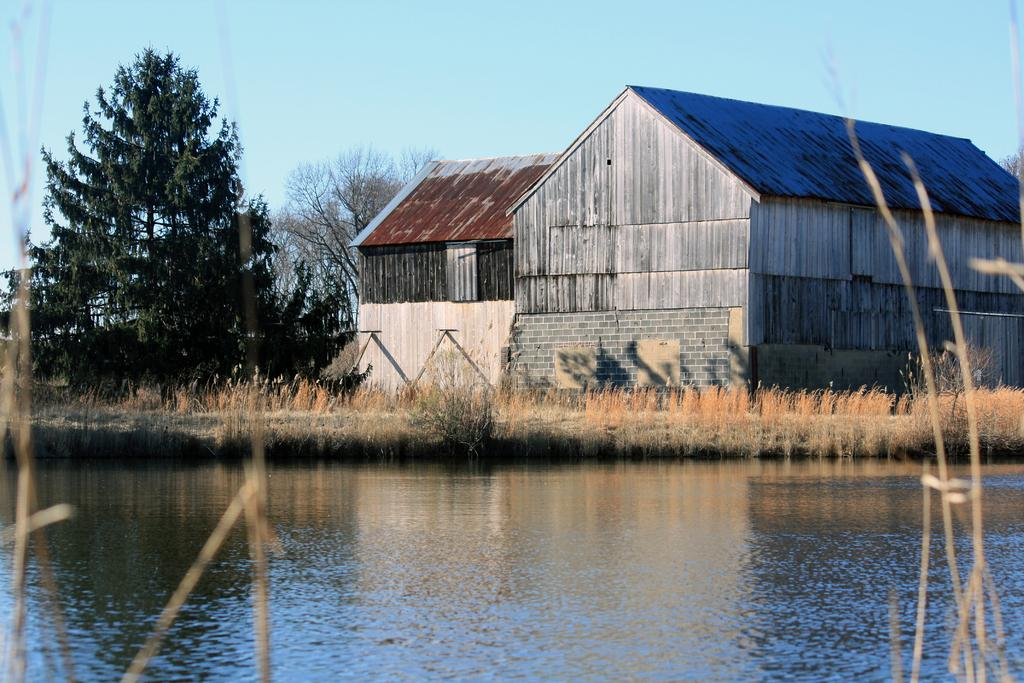What is the primary element visible in the image? There is water in the image. What can be seen in the distance behind the water? There are buildings with roofs and trees in the background. What type of vegetation is present on the ground? There is grass on the ground. What color is the sky in the image? The sky is blue in the image. How many hens are sitting on the grass in the image? There are no hens present in the image. What type of bit is being used to cut the trees in the background? There is no bit or tree-cutting activity depicted in the image. 